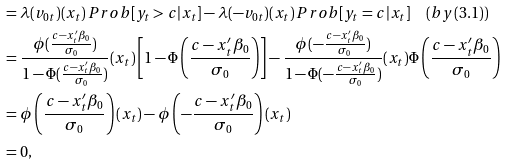Convert formula to latex. <formula><loc_0><loc_0><loc_500><loc_500>& = \lambda ( v _ { 0 t } ) ( x _ { t } ) \, P r o b [ y _ { t } > c | x _ { t } ] - \lambda ( - v _ { 0 t } ) ( x _ { t } ) \, P r o b [ y _ { t } = c | x _ { t } ] \quad ( b y ( 3 . 1 ) ) \\ & = \frac { \phi ( \frac { c - x ^ { \prime } _ { t } \beta _ { 0 } } { \sigma _ { 0 } } ) } { 1 - \Phi ( \frac { c - x ^ { \prime } _ { t } \beta _ { 0 } } { \sigma _ { 0 } } ) } ( x _ { t } ) \left [ 1 - \Phi \left ( \frac { c - x ^ { \prime } _ { t } \beta _ { 0 } } { \sigma _ { 0 } } \right ) \right ] - \frac { \phi ( - \frac { c - x ^ { \prime } _ { t } \beta _ { 0 } } { \sigma _ { 0 } } ) } { 1 - \Phi ( - \frac { c - x ^ { \prime } _ { t } \beta _ { 0 } } { \sigma _ { 0 } } ) } ( x _ { t } ) \Phi \left ( \frac { c - x ^ { \prime } _ { t } \beta _ { 0 } } { \sigma _ { 0 } } \right ) \\ & = \phi \left ( \frac { c - x ^ { \prime } _ { t } \beta _ { 0 } } { \sigma _ { 0 } } \right ) ( x _ { t } ) - \phi \left ( - \frac { c - x ^ { \prime } _ { t } \beta _ { 0 } } { \sigma _ { 0 } } \right ) ( x _ { t } ) \\ & = 0 ,</formula> 